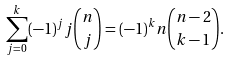<formula> <loc_0><loc_0><loc_500><loc_500>\sum _ { j = 0 } ^ { k } ( - 1 ) ^ { j } j \binom { n } { j } = ( - 1 ) ^ { k } n \binom { n - 2 } { k - 1 } .</formula> 